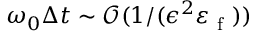<formula> <loc_0><loc_0><loc_500><loc_500>\omega _ { 0 } \Delta t \sim \mathcal { O } ( 1 / ( \epsilon ^ { 2 } \varepsilon _ { f } ) )</formula> 